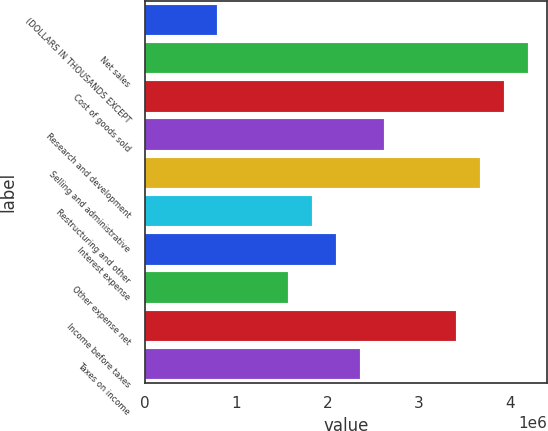Convert chart to OTSL. <chart><loc_0><loc_0><loc_500><loc_500><bar_chart><fcel>(DOLLARS IN THOUSANDS EXCEPT<fcel>Net sales<fcel>Cost of goods sold<fcel>Research and development<fcel>Selling and administrative<fcel>Restructuring and other<fcel>Interest expense<fcel>Other expense net<fcel>Income before taxes<fcel>Taxes on income<nl><fcel>786861<fcel>4.19658e+06<fcel>3.93429e+06<fcel>2.62286e+06<fcel>3.67201e+06<fcel>1.836e+06<fcel>2.09829e+06<fcel>1.57372e+06<fcel>3.40972e+06<fcel>2.36058e+06<nl></chart> 